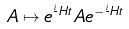Convert formula to latex. <formula><loc_0><loc_0><loc_500><loc_500>A \mapsto e ^ { \frac { i } { } H t } A e ^ { - \frac { i } { } H t }</formula> 